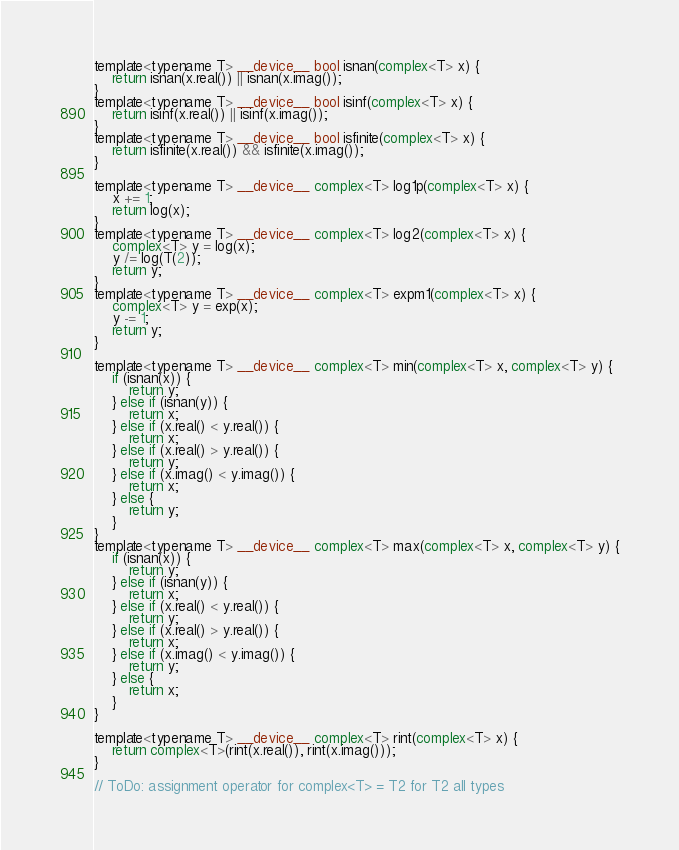<code> <loc_0><loc_0><loc_500><loc_500><_Cuda_>template<typename T> __device__ bool isnan(complex<T> x) {
    return isnan(x.real()) || isnan(x.imag());
}
template<typename T> __device__ bool isinf(complex<T> x) {
    return isinf(x.real()) || isinf(x.imag());
}
template<typename T> __device__ bool isfinite(complex<T> x) {
    return isfinite(x.real()) && isfinite(x.imag());
}

template<typename T> __device__ complex<T> log1p(complex<T> x) {
    x += 1;
    return log(x);
}
template<typename T> __device__ complex<T> log2(complex<T> x) {
    complex<T> y = log(x);
    y /= log(T(2));
    return y;
}
template<typename T> __device__ complex<T> expm1(complex<T> x) {
    complex<T> y = exp(x);
    y -= 1;
    return y;
}

template<typename T> __device__ complex<T> min(complex<T> x, complex<T> y) {
    if (isnan(x)) {
        return y;
    } else if (isnan(y)) {
        return x;
    } else if (x.real() < y.real()) {
        return x;
    } else if (x.real() > y.real()) {
        return y;
    } else if (x.imag() < y.imag()) {
        return x;
    } else {
        return y;
    }
}
template<typename T> __device__ complex<T> max(complex<T> x, complex<T> y) {
    if (isnan(x)) {
        return y;
    } else if (isnan(y)) {
        return x;
    } else if (x.real() < y.real()) {
        return y;
    } else if (x.real() > y.real()) {
        return x;
    } else if (x.imag() < y.imag()) {
        return y;
    } else {
        return x;
    }
}

template<typename T> __device__ complex<T> rint(complex<T> x) {
    return complex<T>(rint(x.real()), rint(x.imag()));
}

// ToDo: assignment operator for complex<T> = T2 for T2 all types
</code> 